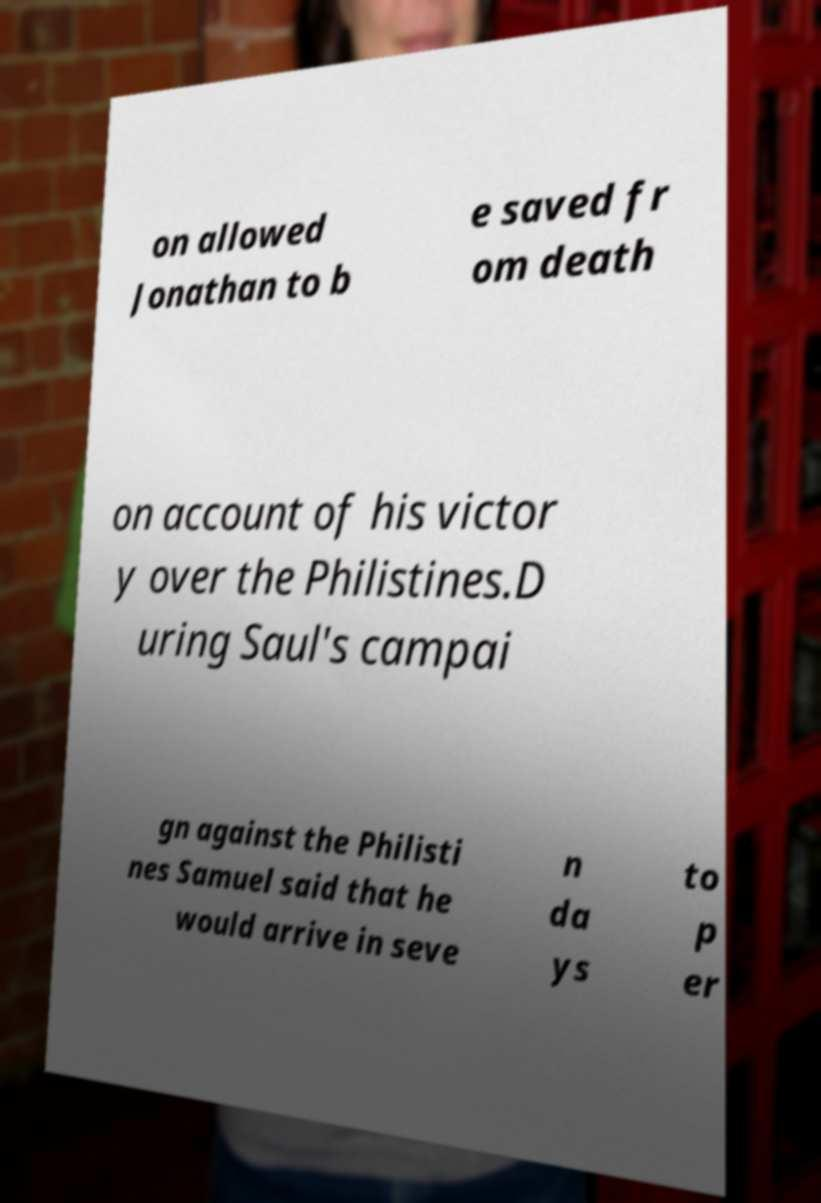For documentation purposes, I need the text within this image transcribed. Could you provide that? on allowed Jonathan to b e saved fr om death on account of his victor y over the Philistines.D uring Saul's campai gn against the Philisti nes Samuel said that he would arrive in seve n da ys to p er 